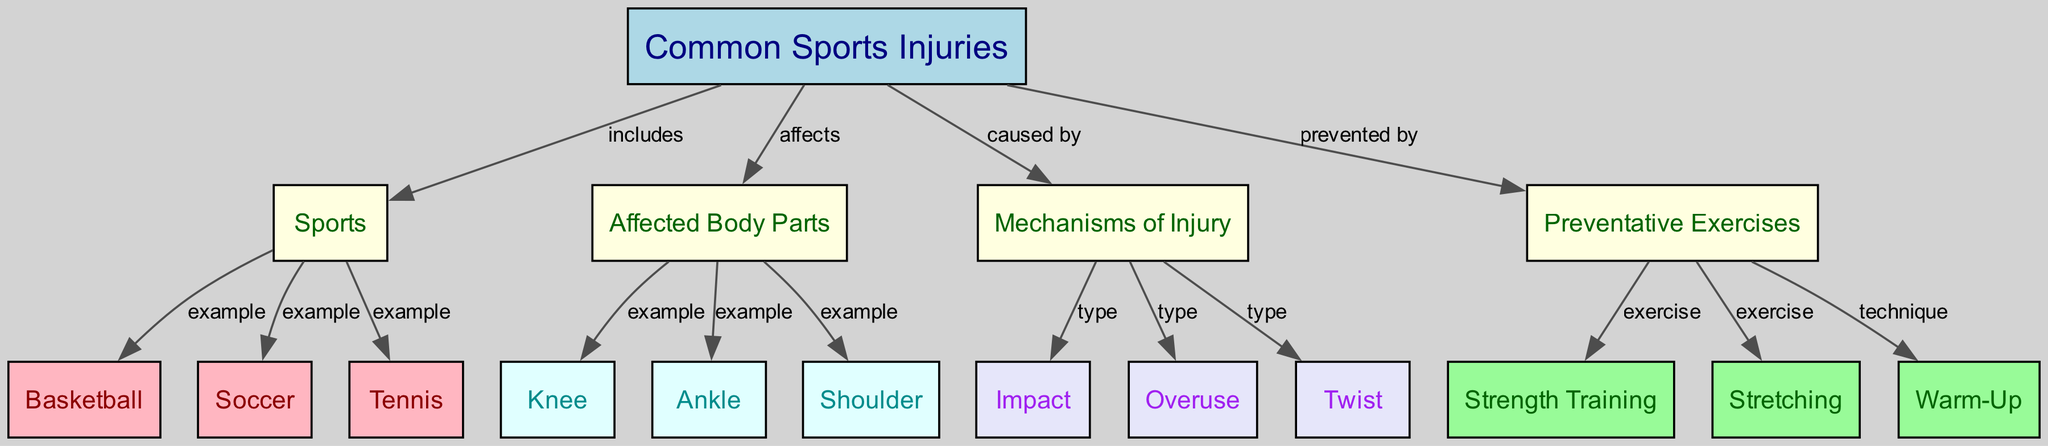What types of sports are included in this diagram? The diagram lists basketball, soccer, and tennis as examples of sports under the "Sports" node, which is directly connected to "Common Sports Injuries" node.
Answer: Basketball, Soccer, Tennis Which body part is affected by common sports injuries? The "Affected Body Parts" node connects with three specific examples: knee, ankle, and shoulder, indicating these body parts are affected by common sports injuries.
Answer: Knee, Ankle, Shoulder How many mechanisms of injury are identified in the diagram? The "Mechanisms of Injury" node is connected to three different types: impact, overuse, and twist, which shows a total of three mechanisms of injury.
Answer: 3 What type of exercise can help prevent injuries? The "Preventative Exercises" node is connected to strength training, stretching, and warm-up, indicating these exercises are known to help prevent injuries.
Answer: Strength Training, Stretching, Warm-Up What causes the injuries identified in the diagram? The "Common Sports Injuries" node is linked to the "Mechanisms of Injury" node which identifies that injuries can be caused by impact, overuse, or twist, thus summarizing the causes of these injuries.
Answer: Impact, Overuse, Twist What color represents the "Common Sports Injuries" node in the diagram? The "Common Sports Injuries" node is colored light blue, distinguishing it visually from other nodes in the diagram.
Answer: Light Blue Which body part is commonly affected by soccer injuries? The diagram indicates that the affected body parts from soccer injuries include the knee and ankle, highlighting these two body areas specifically in relation to soccer.
Answer: Knee, Ankle What is one preventative technique highlighted for sports injuries? The diagram emphasizes warm-up as a technique to prevent injuries, highlighting its importance in injury avoidance during sports activities.
Answer: Warm-Up 